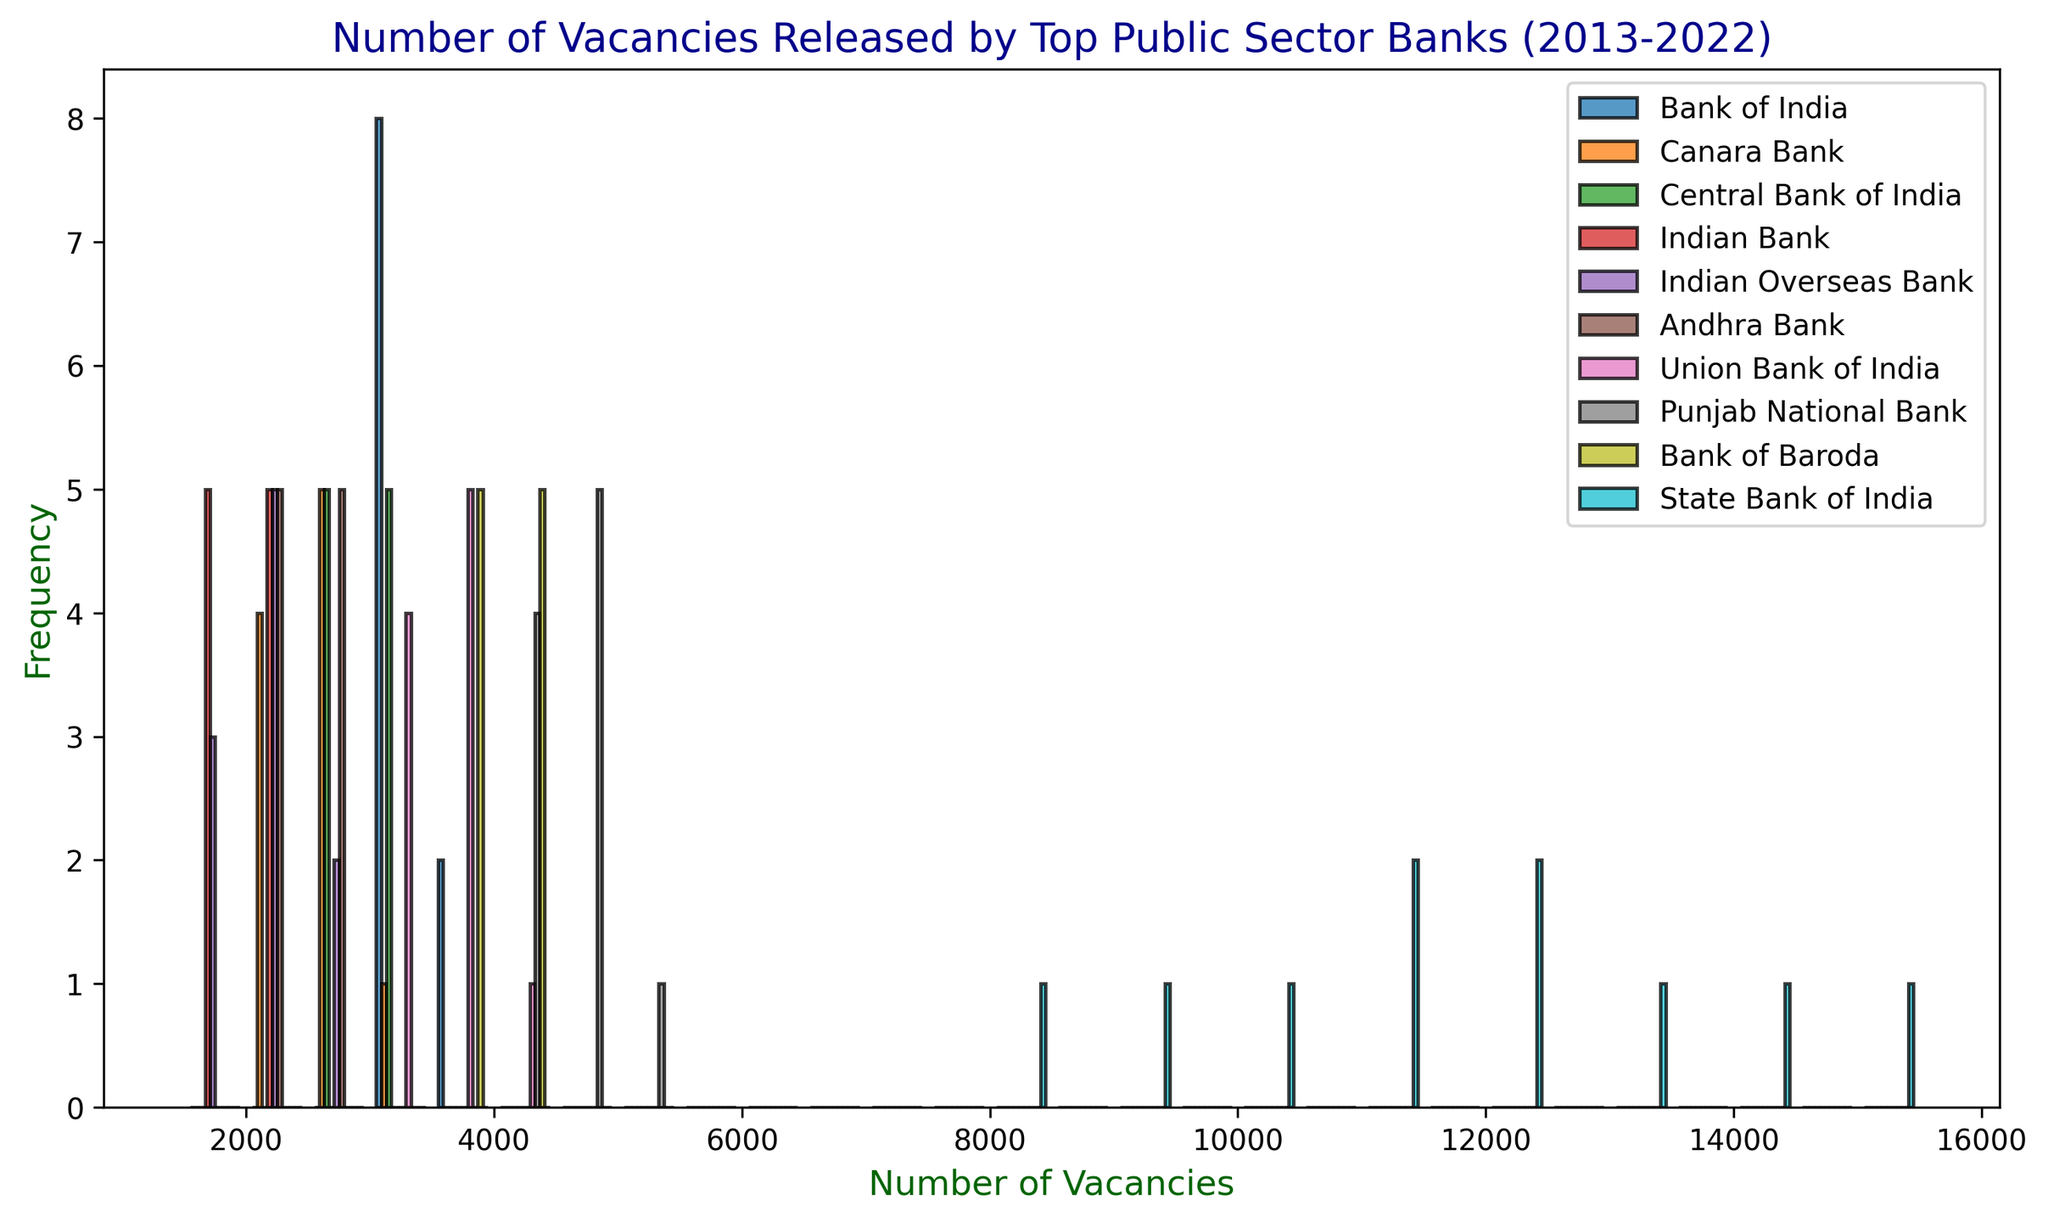How many banks released between 7,500 and 10,000 vacancies the most frequently? Look at the histogram range between 7,500 and 10,000 vacancies. Count the bars that fall within this range.
Answer: 1 Which bank released the highest number of vacancies in 2022? Check the heights of the bars corresponding to 2022. Identify the tallest bar and refer to its label.
Answer: State Bank of India Comparing 2013 and 2018, which year had more banks releasing between 2,500 and 3,500 vacancies? Look at the histogram ranges of 2,500 to 3,500 vacancies for both 2013 and 2018. Count the number of bars in this range for each year.
Answer: 2018 What is the total number of banks that released vacancies in the range of 1,500 to 2,500 in 2016? Check the histogram bins between 1,500 and 2,500 for 2016 and count the bars within this range.
Answer: 2 How many banks released between 12,000 and 15,000 vacancies in 2021? Look at the histogram range between 12,000 and 15,000 vacancies for 2021 and count the bars in this bin.
Answer: 1 Which year had the most banks releasing vacancies in the 3,000 to 4,000 range? Look at the 3,000 to 4,000 range across the years. Compare the number of bars in this range for each year.
Answer: 2022 Determine the trend of vacancies released by Bank of Baroda over the decade. Observe the bar heights corresponding to Bank of Baroda across the years 2013 to 2022. Note if the bars generally rise, fall, or stay constant.
Answer: Increasing Which two banks have the highest number of bars in the histogram? Count the bars attributed to each bank. Identify the two banks with the highest counts.
Answer: State Bank of India, Punjab National Bank 